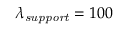<formula> <loc_0><loc_0><loc_500><loc_500>\lambda _ { s u p p o r t } = 1 0 0</formula> 